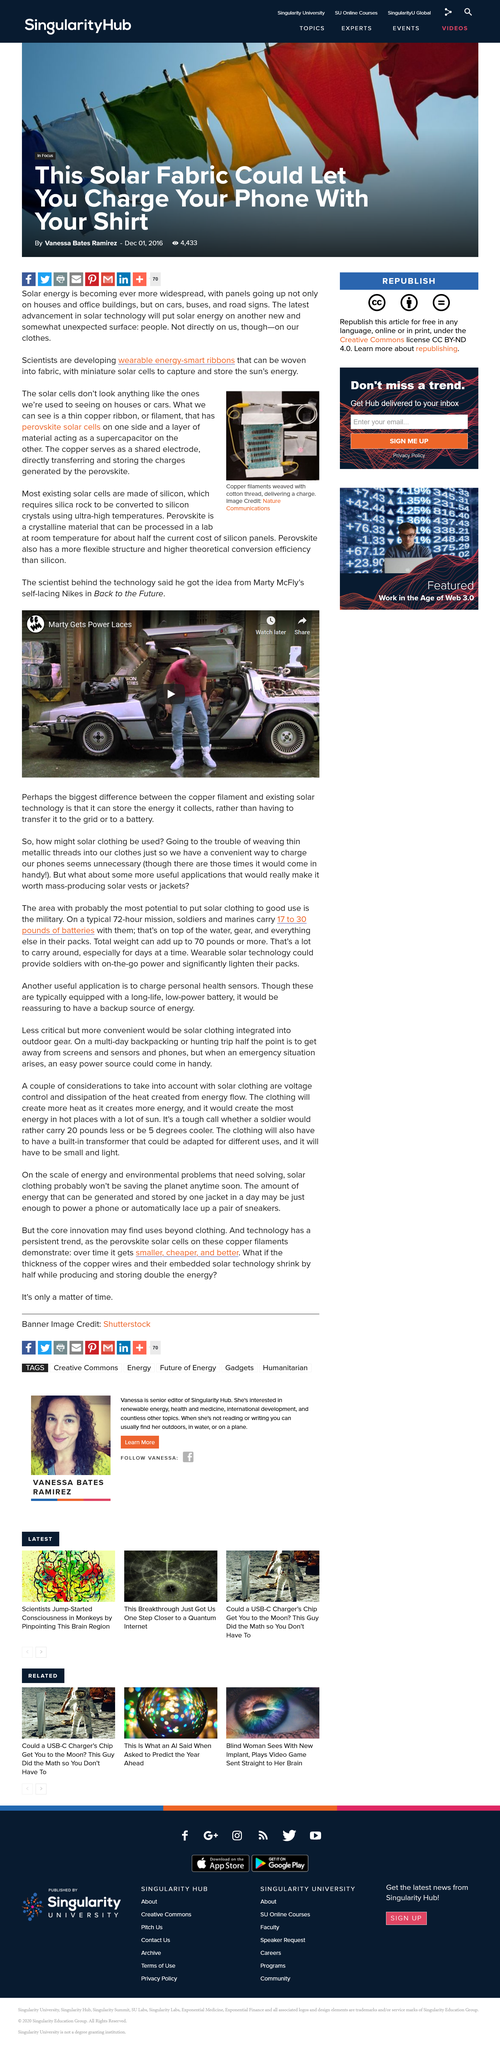Highlight a few significant elements in this photo. The copper plays a critical role in the efficiency of the perovskite solar cells. As a shared electrode, it directly transfers and stores the charges generated by the perovskite, allowing for the efficient conversion of sunlight into electrical energy. Solar cells, which are widely used in renewable energy sources, are primarily made of silicon. The character in the movie wears self-lacing shoes manufactured by Nike. Perovskite is a type of crystalline material that can be processed in a laboratory at room temperature for significantly lower cost than current silicon panels. The article highlights the contrast between copper filament and existing solar technology, drawing attention to the unique features and advantages of copper filament in the field of renewable energy. 